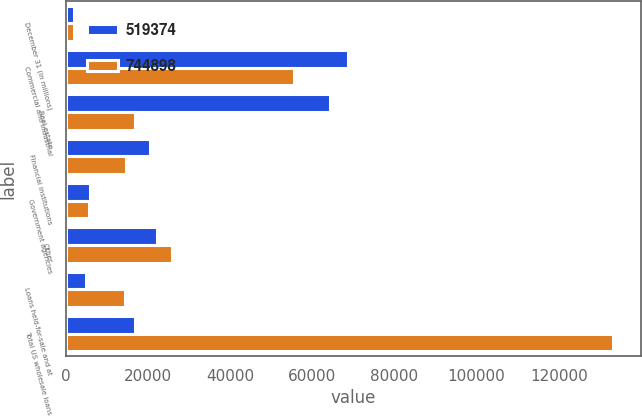<chart> <loc_0><loc_0><loc_500><loc_500><stacked_bar_chart><ecel><fcel>December 31 (in millions)<fcel>Commercial and industrial<fcel>Real estate<fcel>Financial institutions<fcel>Government agencies<fcel>Other<fcel>Loans held-for-sale and at<fcel>Total US wholesale loans<nl><fcel>519374<fcel>2008<fcel>68709<fcel>64214<fcel>20615<fcel>5918<fcel>22330<fcel>4990<fcel>16748<nl><fcel>744898<fcel>2007<fcel>55655<fcel>16748<fcel>14757<fcel>5770<fcel>25883<fcel>14440<fcel>133253<nl></chart> 